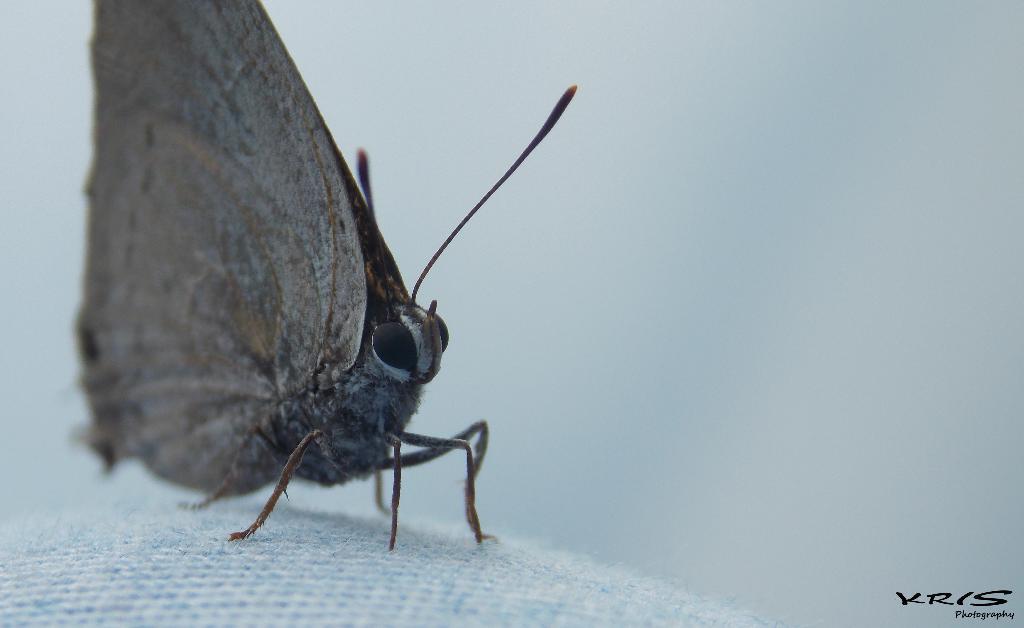Please provide a concise description of this image. In this picture we can see a butterfly on a cloth and in the background it is blurry and at the bottom right corner we can see some text. 